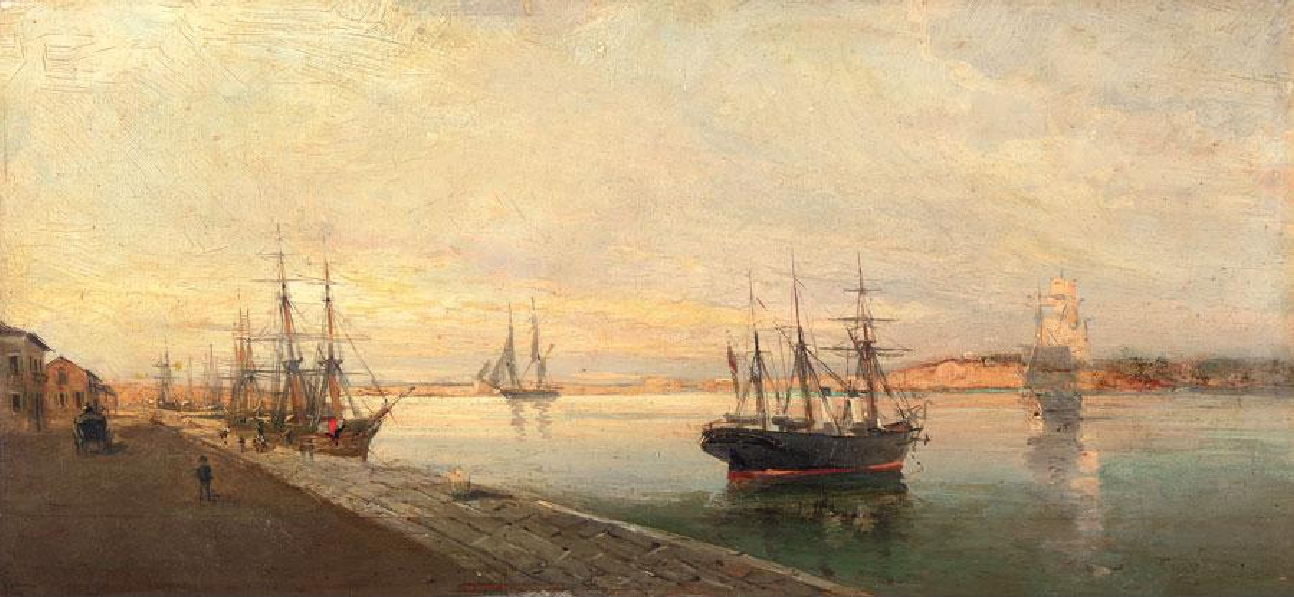Can you create a fantastical story inspired by this painting? In a quiet harbor bathed in the golden hues of a setting sun, a fleet of ships prepared for a journey not of this world. These were no ordinary vessels—each ship was equipped with sails woven from starlight and masts carved from enchanted forest trees. The harbor, hidden from the mundane eye, was a meeting place for explorers of celestial realms. Once a year, as the stars aligned, these ships would embark on a voyage across the skies to collect stardust and whispers of ancient spirits. The sailors, guardians of galactic secrets, navigated through constellations and cosmic winds, their hearts filled with the wonder of the universe. As they departed, the gentle breeze carried away the melodies of otherworldly harps and the smell of ethereal blooms, leaving behind a magical tranquility that lingered long after the ships had soared into the twilight. 